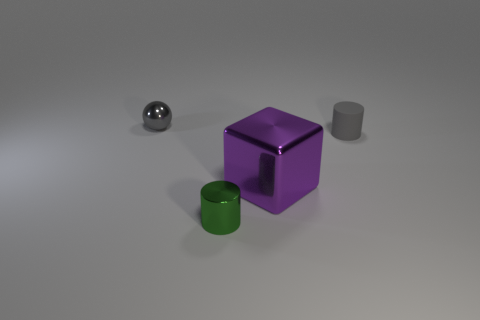There is a cylinder that is made of the same material as the large purple block; what is its color?
Your answer should be very brief. Green. There is a gray thing that is in front of the small gray object on the left side of the tiny cylinder right of the large purple metallic thing; what shape is it?
Ensure brevity in your answer.  Cylinder. The metal cube has what size?
Offer a terse response. Large. What is the shape of the big purple object that is made of the same material as the small green thing?
Provide a short and direct response. Cube. Are there fewer big purple objects that are behind the large object than rubber things?
Your answer should be very brief. Yes. What color is the tiny thing that is behind the tiny gray cylinder?
Your answer should be compact. Gray. What material is the sphere that is the same color as the small rubber thing?
Keep it short and to the point. Metal. Is there a big cyan thing that has the same shape as the big purple object?
Ensure brevity in your answer.  No. What number of other things are the same shape as the large purple metal object?
Offer a very short reply. 0. Is the color of the metallic block the same as the small metal cylinder?
Give a very brief answer. No. 